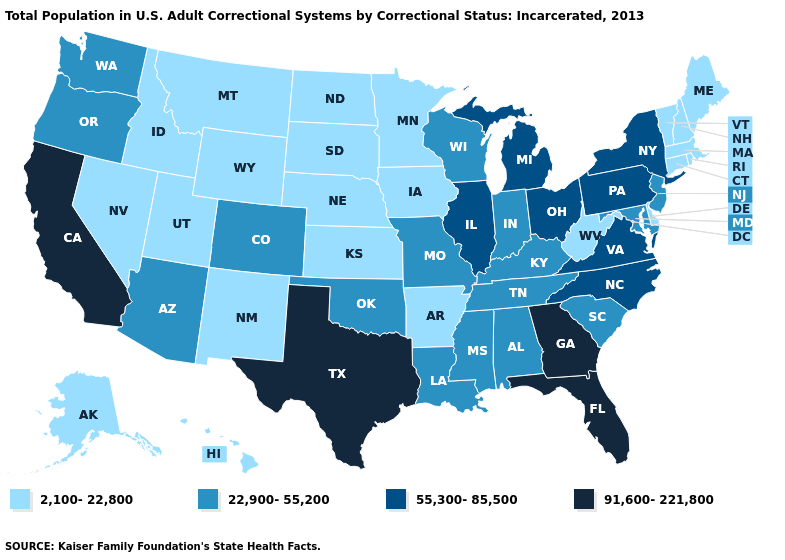What is the lowest value in states that border Montana?
Short answer required. 2,100-22,800. Which states hav the highest value in the Northeast?
Write a very short answer. New York, Pennsylvania. What is the value of Utah?
Write a very short answer. 2,100-22,800. Is the legend a continuous bar?
Short answer required. No. What is the value of Montana?
Concise answer only. 2,100-22,800. What is the value of Utah?
Keep it brief. 2,100-22,800. What is the value of Mississippi?
Concise answer only. 22,900-55,200. Which states have the lowest value in the USA?
Give a very brief answer. Alaska, Arkansas, Connecticut, Delaware, Hawaii, Idaho, Iowa, Kansas, Maine, Massachusetts, Minnesota, Montana, Nebraska, Nevada, New Hampshire, New Mexico, North Dakota, Rhode Island, South Dakota, Utah, Vermont, West Virginia, Wyoming. Which states have the lowest value in the USA?
Give a very brief answer. Alaska, Arkansas, Connecticut, Delaware, Hawaii, Idaho, Iowa, Kansas, Maine, Massachusetts, Minnesota, Montana, Nebraska, Nevada, New Hampshire, New Mexico, North Dakota, Rhode Island, South Dakota, Utah, Vermont, West Virginia, Wyoming. Does Nevada have the highest value in the USA?
Answer briefly. No. What is the value of North Carolina?
Give a very brief answer. 55,300-85,500. Does the map have missing data?
Concise answer only. No. What is the value of Connecticut?
Answer briefly. 2,100-22,800. What is the value of Mississippi?
Short answer required. 22,900-55,200. Does Virginia have the lowest value in the USA?
Be succinct. No. 